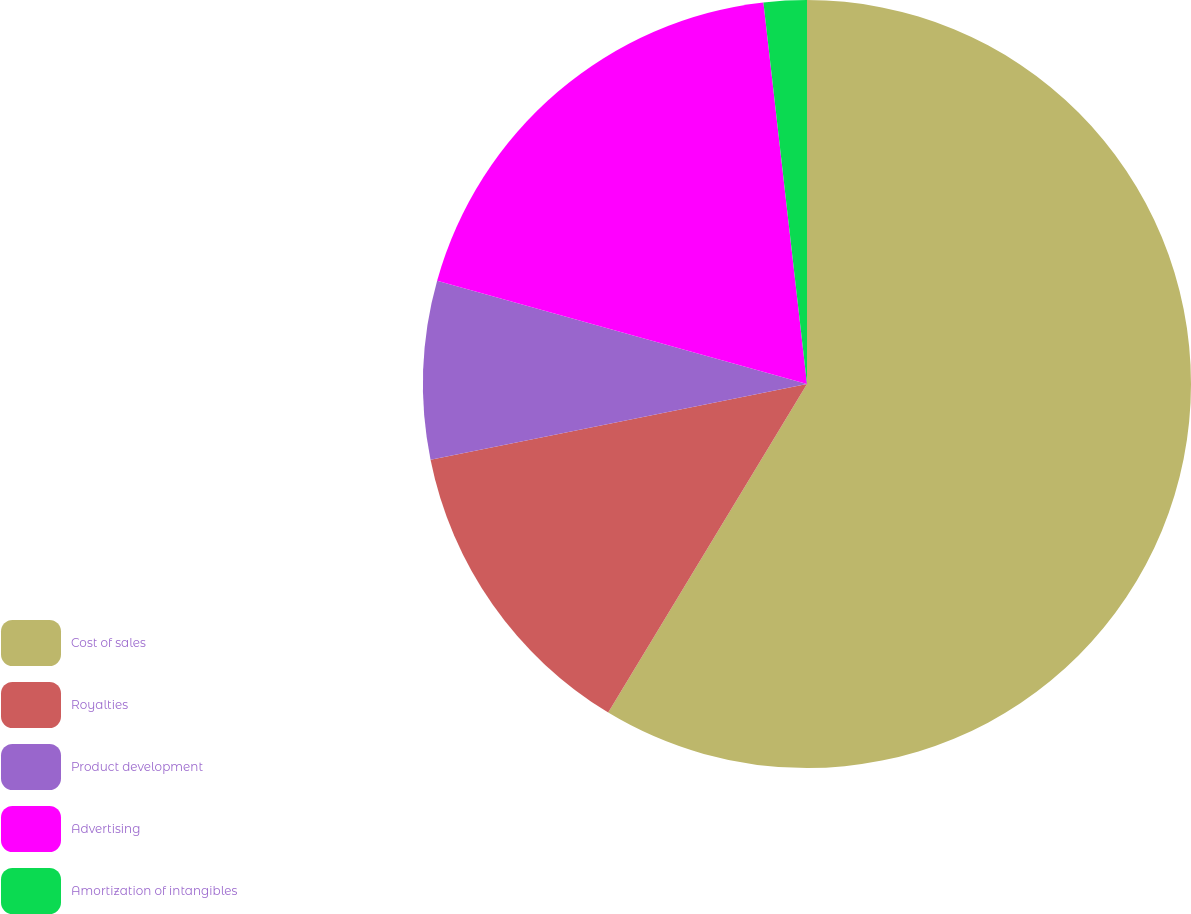Convert chart to OTSL. <chart><loc_0><loc_0><loc_500><loc_500><pie_chart><fcel>Cost of sales<fcel>Royalties<fcel>Product development<fcel>Advertising<fcel>Amortization of intangibles<nl><fcel>58.66%<fcel>13.18%<fcel>7.49%<fcel>18.86%<fcel>1.81%<nl></chart> 